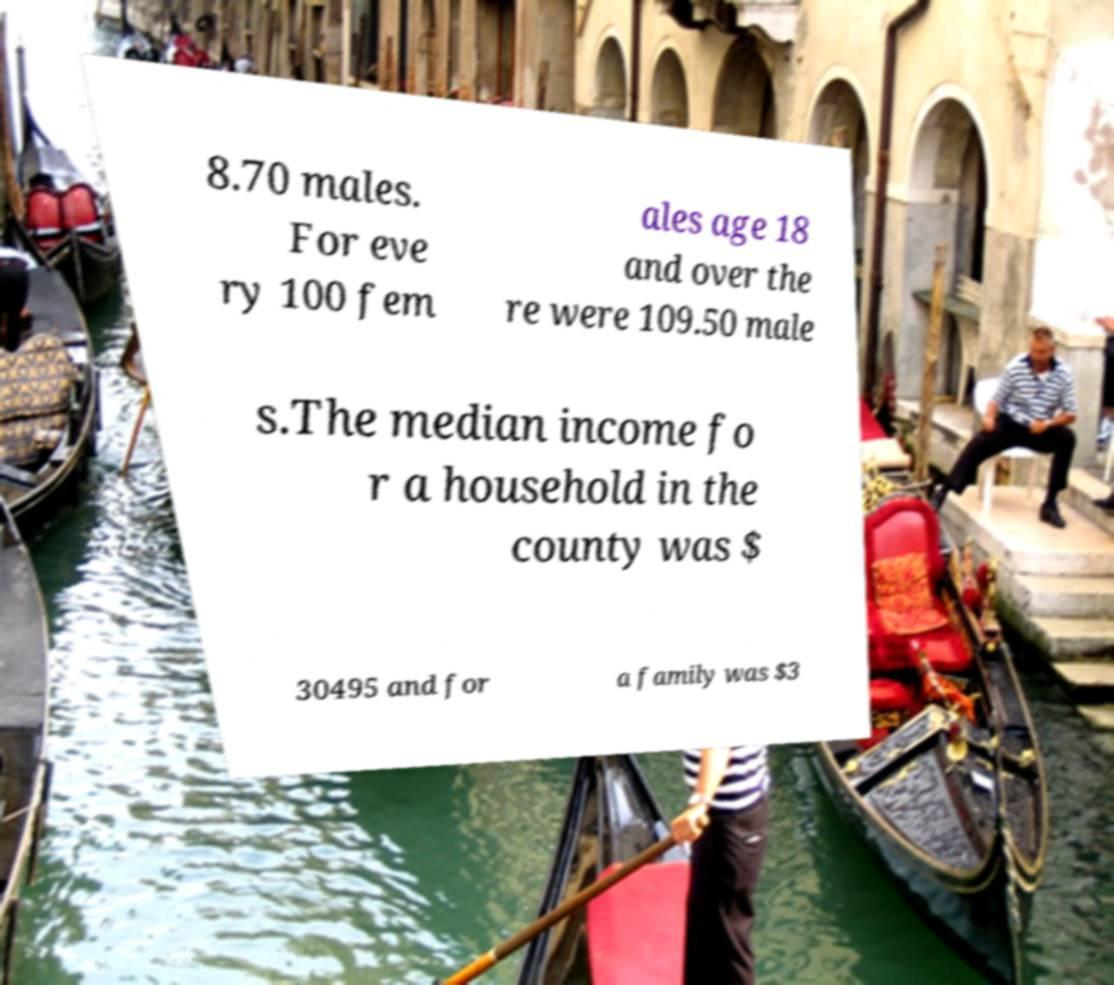For documentation purposes, I need the text within this image transcribed. Could you provide that? 8.70 males. For eve ry 100 fem ales age 18 and over the re were 109.50 male s.The median income fo r a household in the county was $ 30495 and for a family was $3 